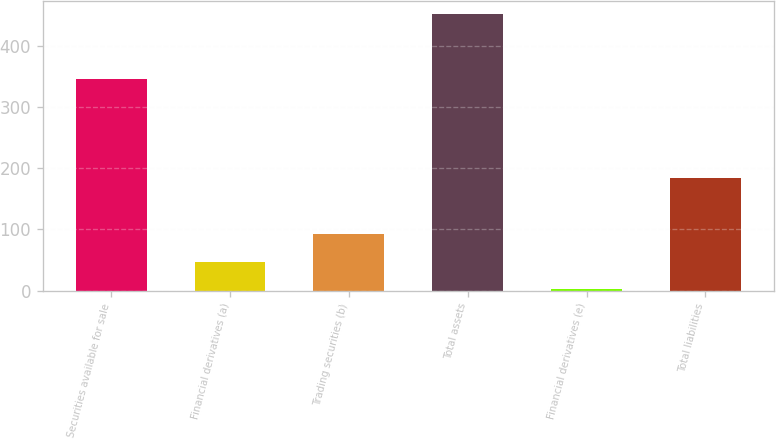Convert chart to OTSL. <chart><loc_0><loc_0><loc_500><loc_500><bar_chart><fcel>Securities available for sale<fcel>Financial derivatives (a)<fcel>Trading securities (b)<fcel>Total assets<fcel>Financial derivatives (e)<fcel>Total liabilities<nl><fcel>347<fcel>47<fcel>92<fcel>452<fcel>2<fcel>184<nl></chart> 